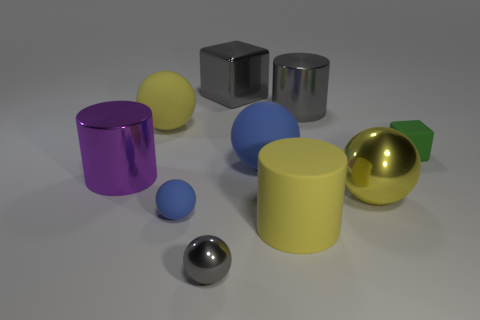Subtract all big yellow matte spheres. How many spheres are left? 4 Subtract all yellow blocks. How many yellow spheres are left? 2 Subtract all yellow spheres. How many spheres are left? 3 Subtract all cylinders. How many objects are left? 7 Subtract 1 cylinders. How many cylinders are left? 2 Subtract all green balls. Subtract all yellow cubes. How many balls are left? 5 Add 5 tiny blue matte objects. How many tiny blue matte objects are left? 6 Add 1 big blue cubes. How many big blue cubes exist? 1 Subtract 0 blue cylinders. How many objects are left? 10 Subtract all big rubber things. Subtract all small green matte blocks. How many objects are left? 6 